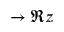<formula> <loc_0><loc_0><loc_500><loc_500>\rightarrow \Re { z }</formula> 